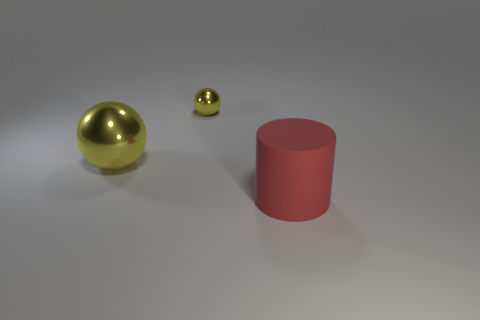Add 2 tiny blue spheres. How many objects exist? 5 Subtract all cylinders. How many objects are left? 2 Subtract 0 red cubes. How many objects are left? 3 Subtract all matte cylinders. Subtract all metallic objects. How many objects are left? 0 Add 1 small yellow things. How many small yellow things are left? 2 Add 3 tiny yellow metal balls. How many tiny yellow metal balls exist? 4 